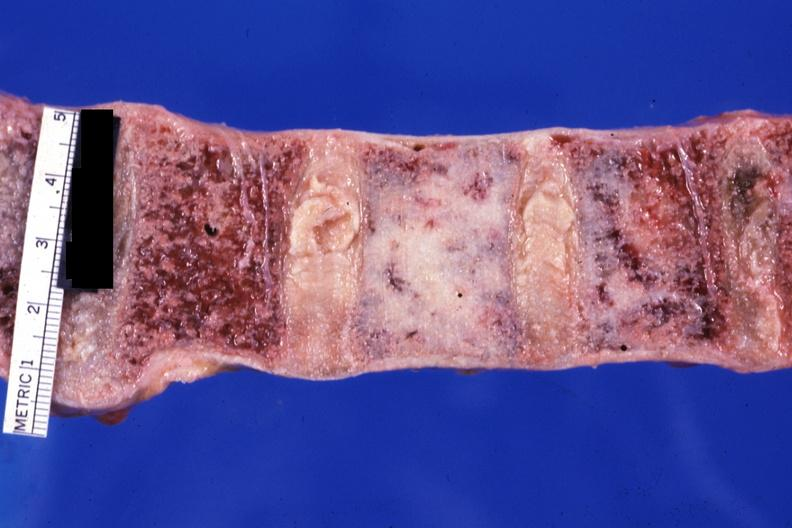what is present?
Answer the question using a single word or phrase. Joints 